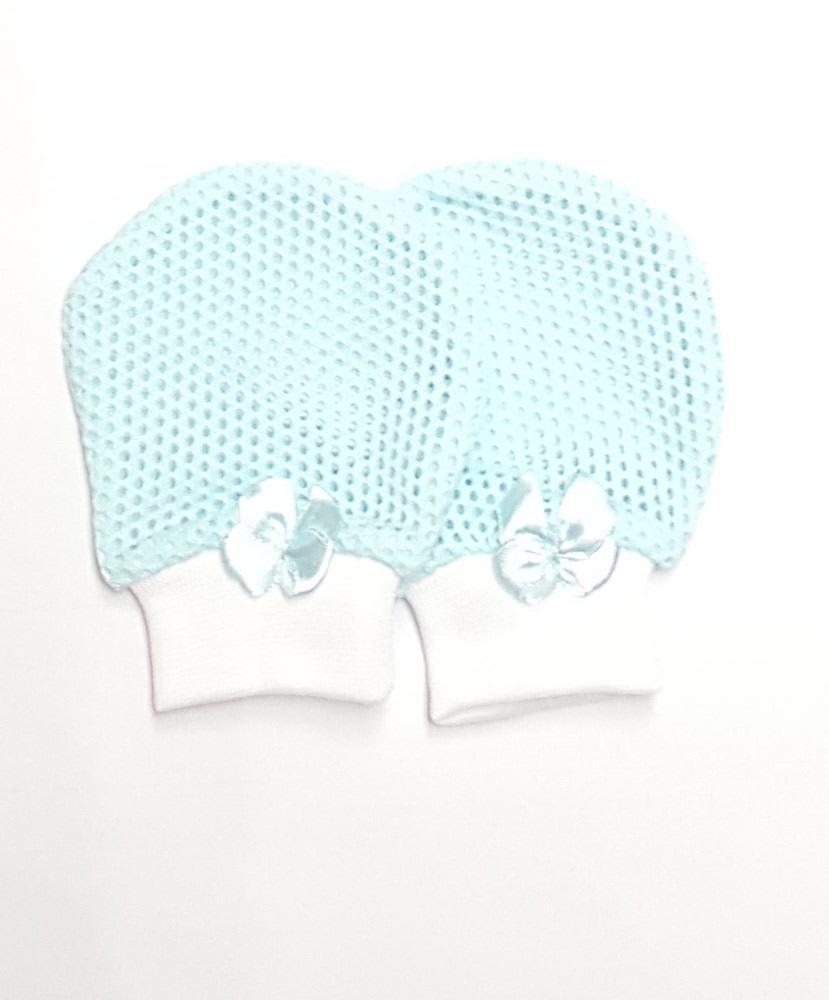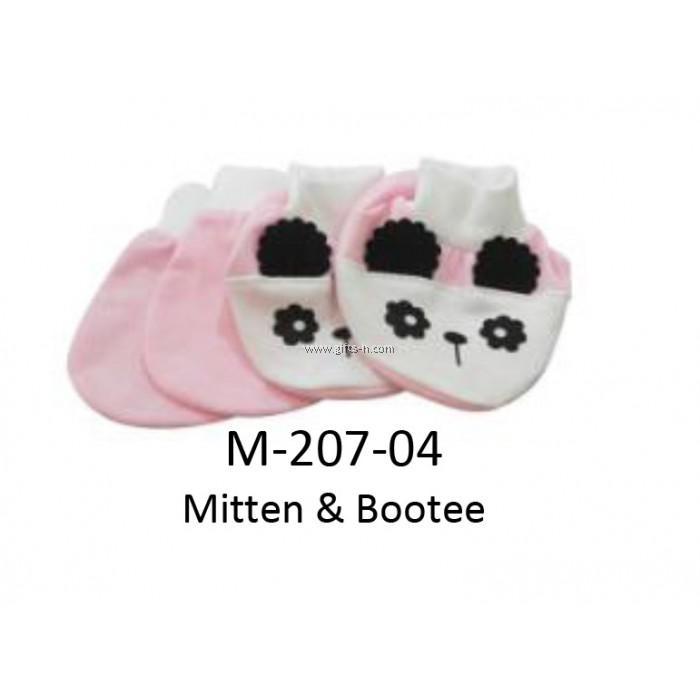The first image is the image on the left, the second image is the image on the right. Given the left and right images, does the statement "The combined images include three paired items, and one paired item features black-and-white eye shapes." hold true? Answer yes or no. Yes. The first image is the image on the left, the second image is the image on the right. For the images displayed, is the sentence "The left and right image contains a total of four mittens and two bootees." factually correct? Answer yes or no. Yes. 